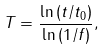Convert formula to latex. <formula><loc_0><loc_0><loc_500><loc_500>T = \frac { \ln { ( t / t _ { 0 } ) } } { \ln { ( 1 / f ) } } ,</formula> 